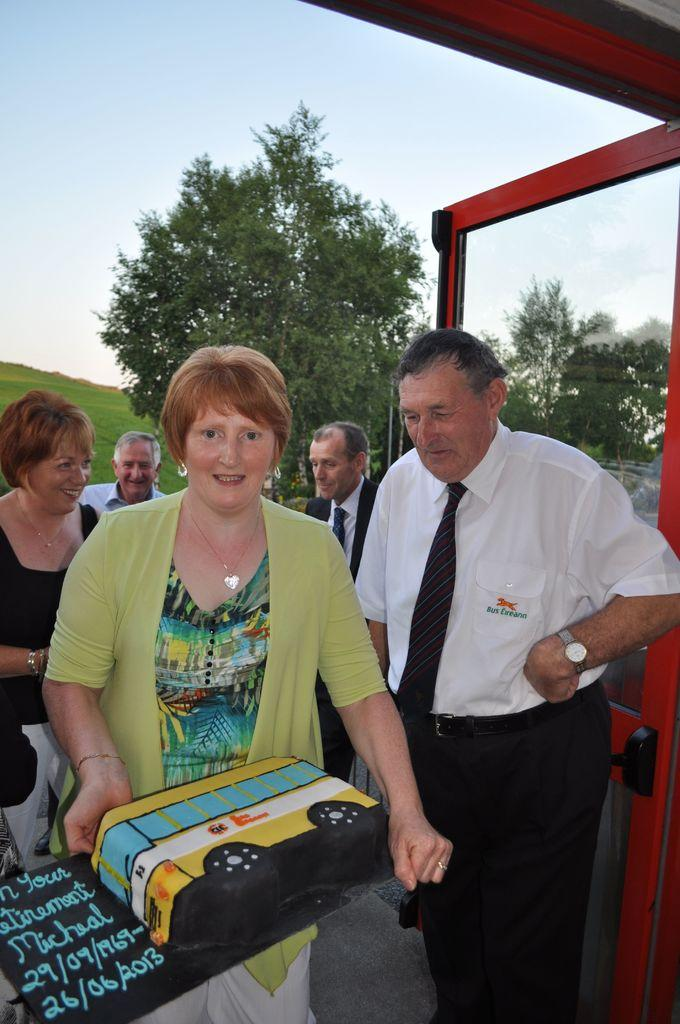Who is the main subject in the image? There is a woman in the image. What is the woman holding in the image? The woman is holding a cake. Can you describe the people standing behind the woman? There are men and women standing behind the woman. What can be seen in the background of the image? There are trees in the background of the image, and the sky is visible above the background. What type of cork can be seen in the image? There is no cork present in the image. Is there a cellar visible in the image? There is no cellar visible in the image. 